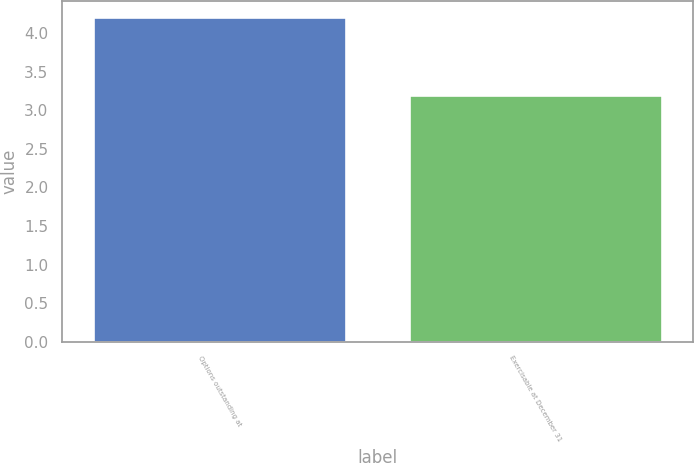<chart> <loc_0><loc_0><loc_500><loc_500><bar_chart><fcel>Options outstanding at<fcel>Exercisable at December 31<nl><fcel>4.2<fcel>3.2<nl></chart> 